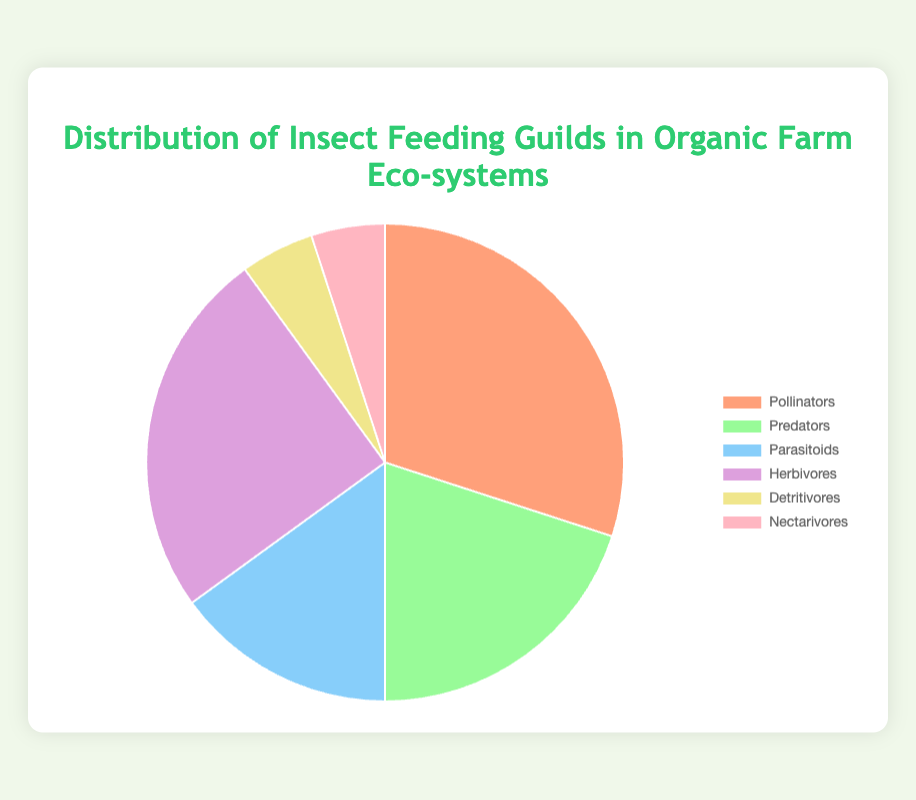Which guild has the highest percentage? To determine the guild with the highest percentage, refer to the dataset and the pie chart. The value for each guild is listed, and the largest value is 30% for Pollinators.
Answer: Pollinators Which two guilds have the lowest percentages and how much do they sum to? Identify the lowest percentages from the dataset, which are 5% for Detritivores and 5% for Nectarivores, and then add them together: 5% + 5% = 10%.
Answer: 10% What is the total percentage of Predators and Herbivores combined? Add the percentage of Predators (20%) and Herbivores (25%) from the dataset: 20% + 25% = 45%.
Answer: 45% How many guilds have a percentage greater than 10%? Count the guilds with percentages greater than 10%: Pollinators (30%), Predators (20%), Parasitoids (15%), and Herbivores (25%), which totals 4 guilds.
Answer: 4 Which color represents the Detritivores? Detritivores have a percentage of 5% and are represented by a specific color. According to the chart's color legend, Detritivores are in yellow.
Answer: Yellow What is the difference in percentage between Pollinators and Parasitoids? Subtract the percentage of Parasitoids (15%) from Pollinators (30%): 30% - 15% = 15%.
Answer: 15% Which guild percentage is closest to the percentage of Nectarivores? Compare the percentage of Nectarivores (5%) with other guilds. Detritivores also have a percentage of 5%, which is identical and therefore closest.
Answer: Detritivores Is the percentage of Herbivores larger or smaller than the combined percentage of Detritivores and Nectarivores? Combine the percentages of Detritivores (5%) and Nectarivores (5%): 5% + 5% = 10%, and compare this with the percentage of Herbivores (25%). Since 25% > 10%, Herbivores are larger.
Answer: Larger 